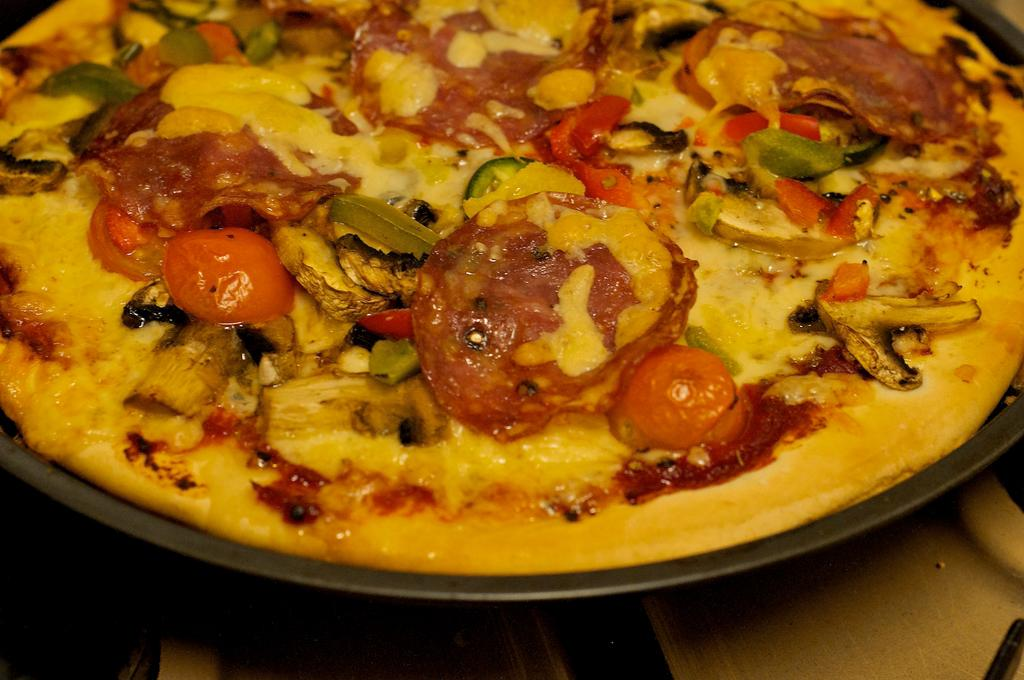What type of food is shown in the image? There is a pizza in the image. How is the pizza being held or supported? The pizza is on a pan. Where is the pan with the pizza located? The pan is visible on a platform. Is there a cake on the sink in the image? There is no mention of a cake or a sink in the provided facts, so we cannot determine if there is a cake on a sink in the image. 